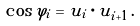<formula> <loc_0><loc_0><loc_500><loc_500>\cos \varphi _ { i } = { u } _ { i } \cdot { u } _ { i + 1 } \, .</formula> 